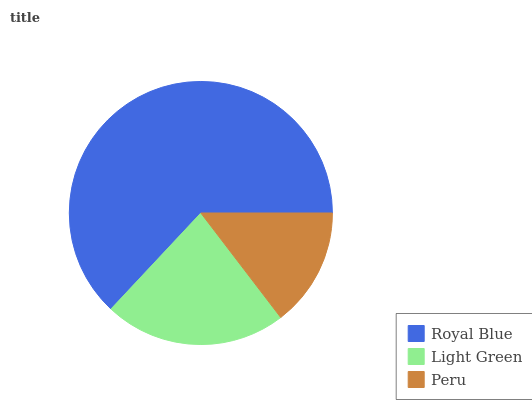Is Peru the minimum?
Answer yes or no. Yes. Is Royal Blue the maximum?
Answer yes or no. Yes. Is Light Green the minimum?
Answer yes or no. No. Is Light Green the maximum?
Answer yes or no. No. Is Royal Blue greater than Light Green?
Answer yes or no. Yes. Is Light Green less than Royal Blue?
Answer yes or no. Yes. Is Light Green greater than Royal Blue?
Answer yes or no. No. Is Royal Blue less than Light Green?
Answer yes or no. No. Is Light Green the high median?
Answer yes or no. Yes. Is Light Green the low median?
Answer yes or no. Yes. Is Royal Blue the high median?
Answer yes or no. No. Is Peru the low median?
Answer yes or no. No. 